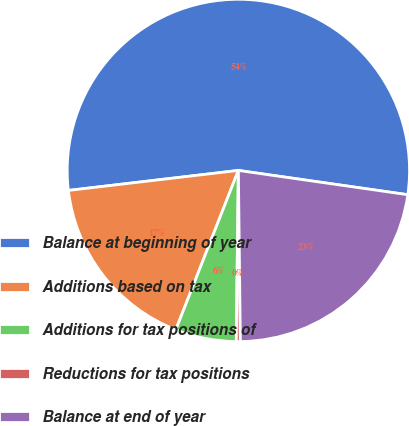Convert chart. <chart><loc_0><loc_0><loc_500><loc_500><pie_chart><fcel>Balance at beginning of year<fcel>Additions based on tax<fcel>Additions for tax positions of<fcel>Reductions for tax positions<fcel>Balance at end of year<nl><fcel>54.13%<fcel>17.18%<fcel>5.76%<fcel>0.38%<fcel>22.55%<nl></chart> 